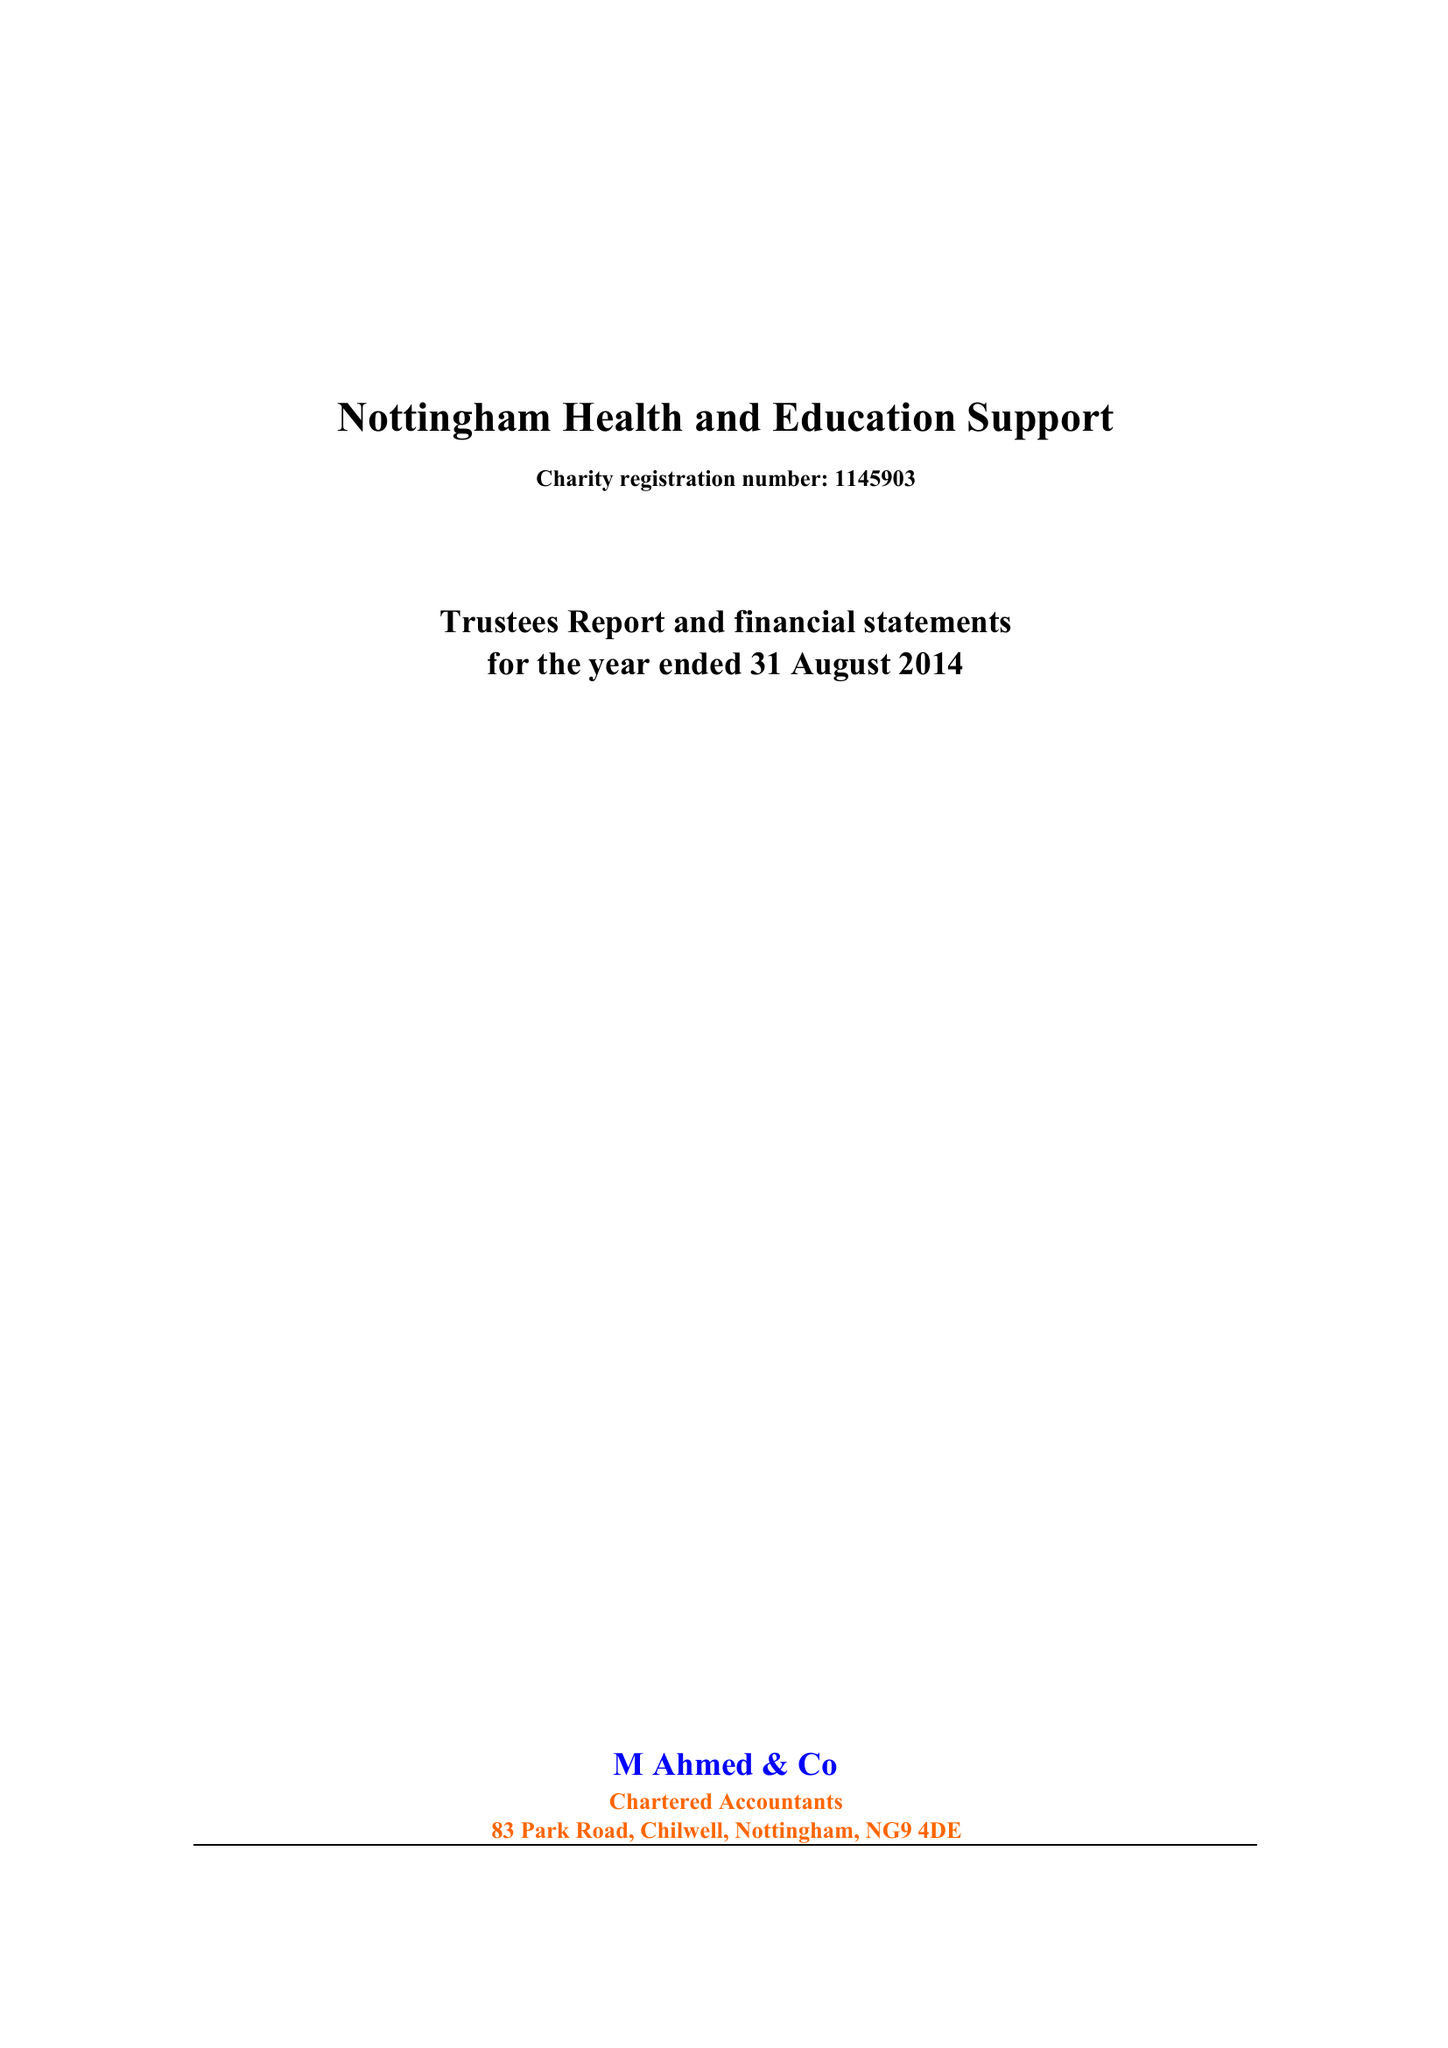What is the value for the report_date?
Answer the question using a single word or phrase. 2014-08-31 